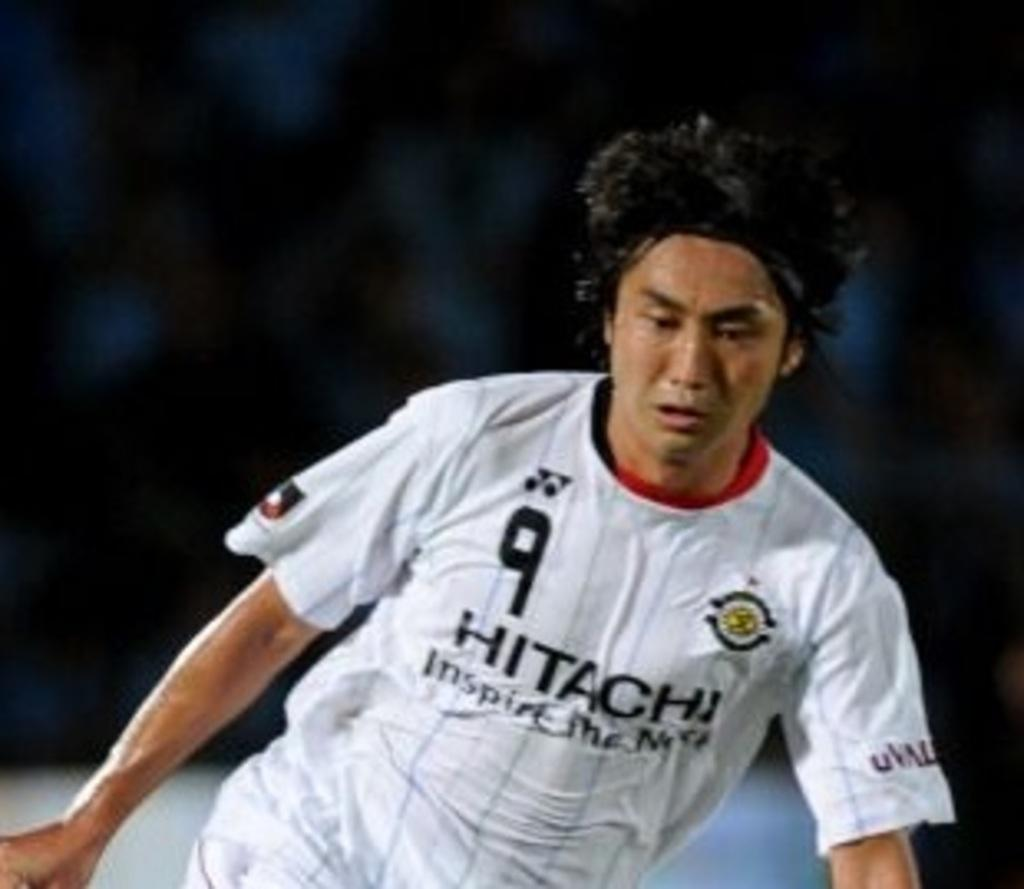Provide a one-sentence caption for the provided image. a boy wearing a white jersey that says '9 hitachi' on it. 